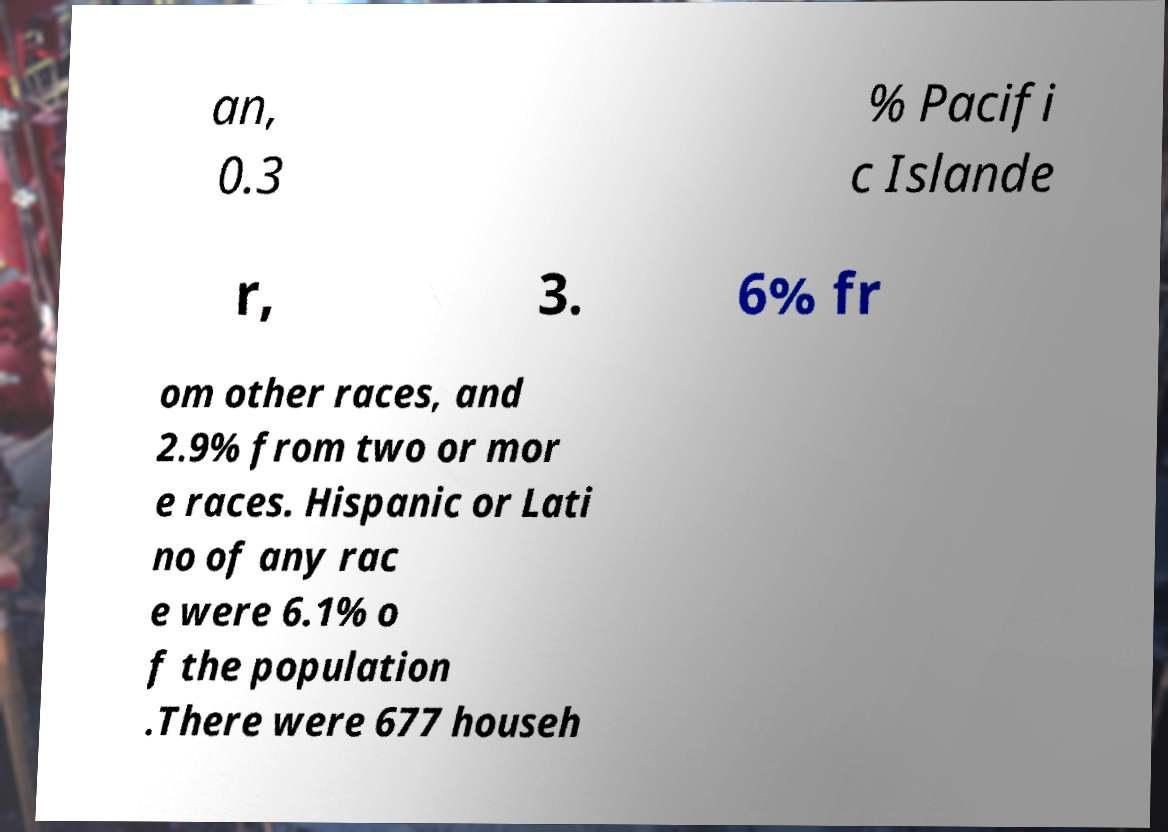For documentation purposes, I need the text within this image transcribed. Could you provide that? an, 0.3 % Pacifi c Islande r, 3. 6% fr om other races, and 2.9% from two or mor e races. Hispanic or Lati no of any rac e were 6.1% o f the population .There were 677 househ 